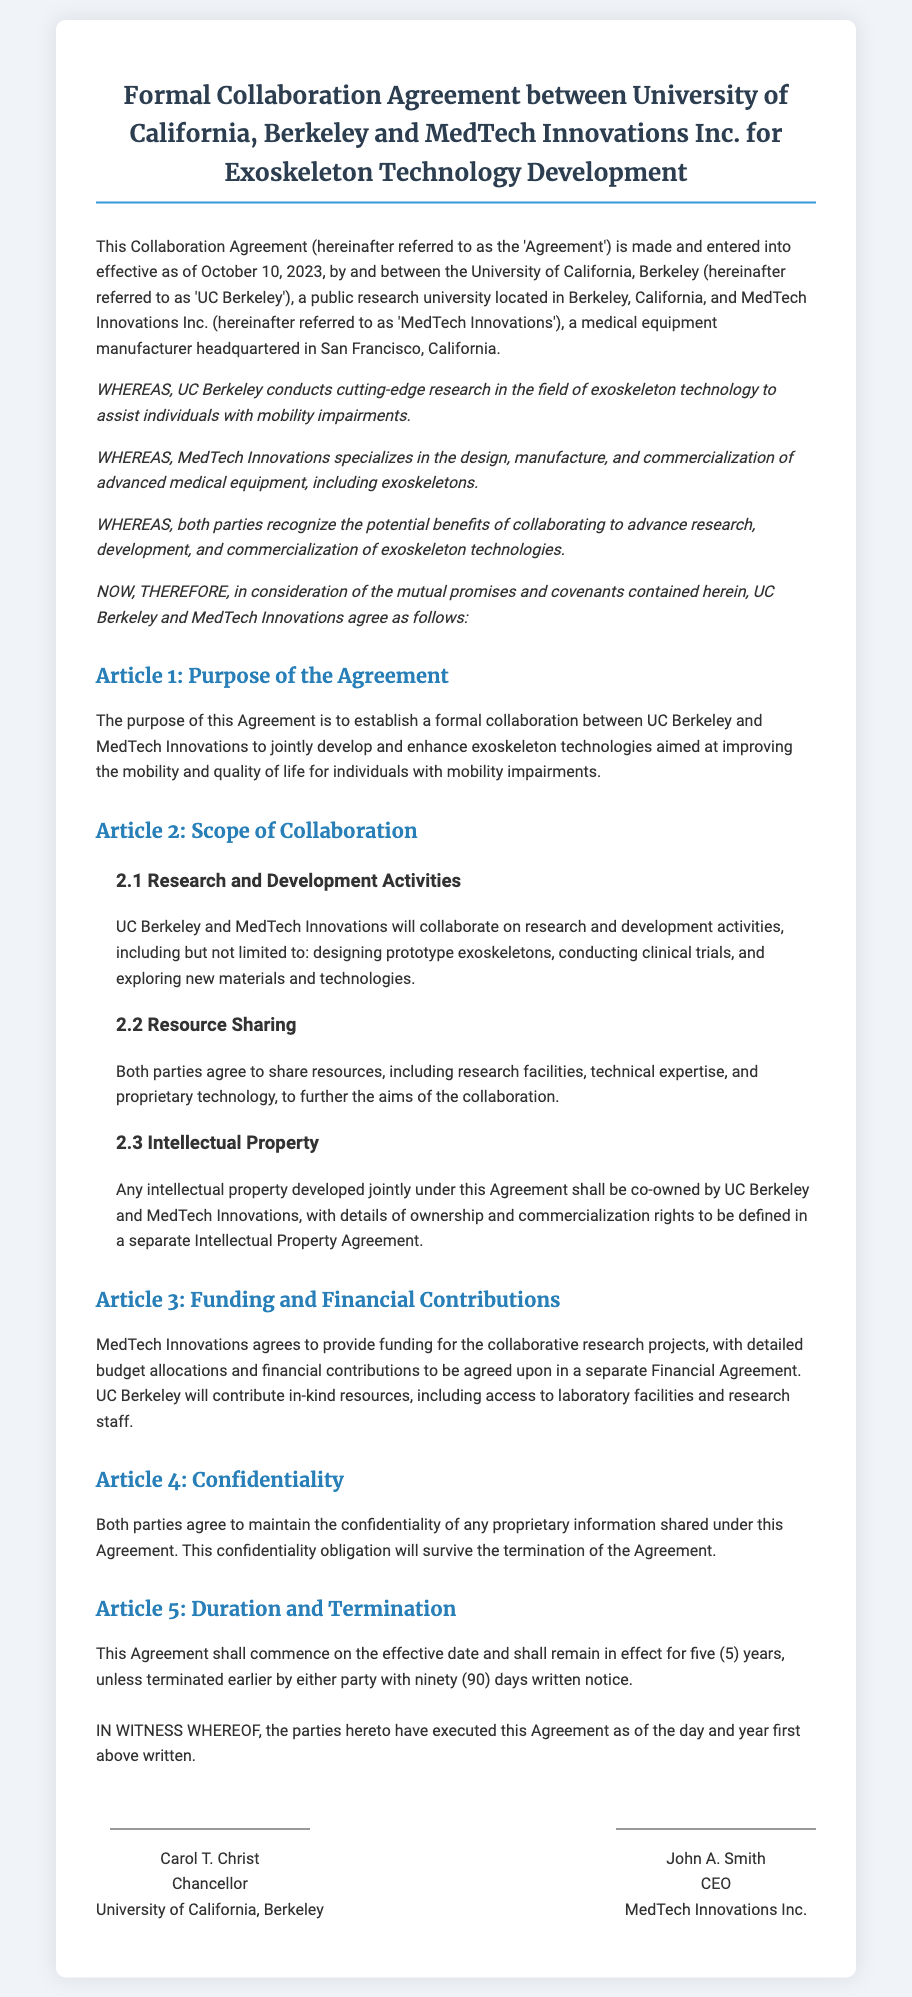What is the effective date of the agreement? The effective date is stated at the beginning of the document, which specifies when the agreement comes into effect.
Answer: October 10, 2023 Who is the Chancellor of UC Berkeley? The document includes the name and title of the signatory representing UC Berkeley.
Answer: Carol T. Christ What is the main purpose of the Agreement? The purpose is detailed in Article 1, summarizing what both parties aim to achieve through this collaboration.
Answer: To establish a formal collaboration for exoskeleton technology development How long is the duration of the Agreement? The duration is stated in Article 5, specifying how long the agreement will remain in effect.
Answer: Five (5) years What is MedTech Innovations' role in the collaboration? The document describes the involvement of MedTech Innovations, particularly in providing resources and funding.
Answer: Provide funding for collaborative research projects What type of information must both parties keep confidential? Article 4 outlines the requirement for confidentiality related to specific types of information shared during the collaboration.
Answer: Proprietary information What will the intellectual property developed under this agreement be classified as? Article 2.3 provides details on how intellectual property will be treated between the two parties.
Answer: Co-owned How much notice is required for termination of the agreement? Article 5 mentions the notice period required for either party to terminate the agreement.
Answer: Ninety (90) days 